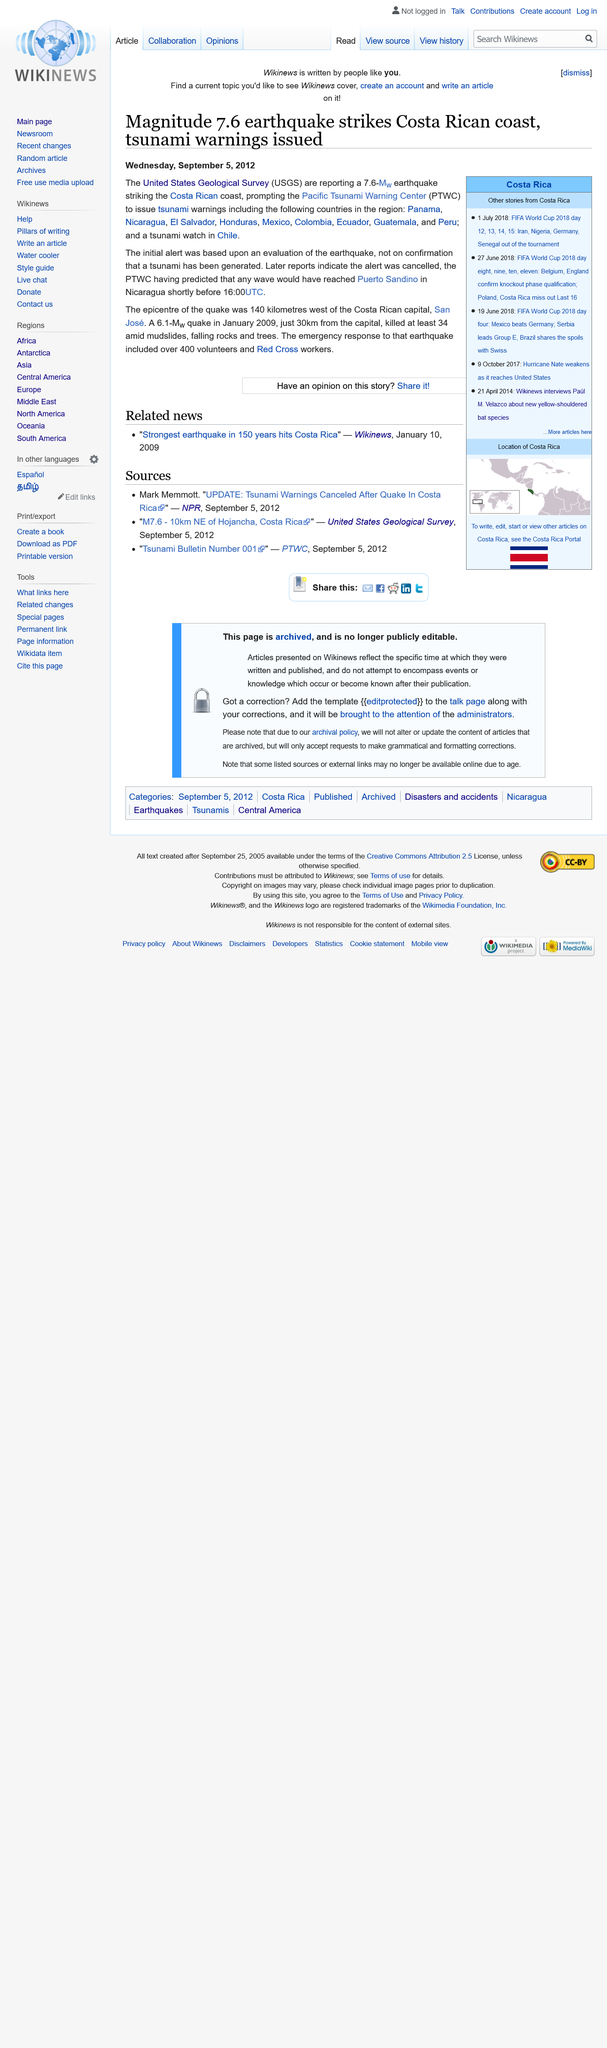Specify some key components in this picture. On January 8th, a 7.6 magnitude earthquake hit the Costa Rican coastline, causing widespread damage and leaving many residents in a state of shock. The earthquake was reported to be one of the largest in recent history, causing panic and disruption across the country. Emergency services were quickly deployed to assess the damage and provide assistance to those affected by the disaster. The Costa Rican government has since declared a state of emergency as the country begins to rebuild in the aftermath of this devastating earthquake. The epicenter of the earthquake was located 140 kilometers west of the Costa Rican capital of San Jose. The Pacific Tsunami Warning Center (PTWC) predicted that waves would reach Puerto Sandino in Nicaragua by 16:00 UTC on a specific date. 